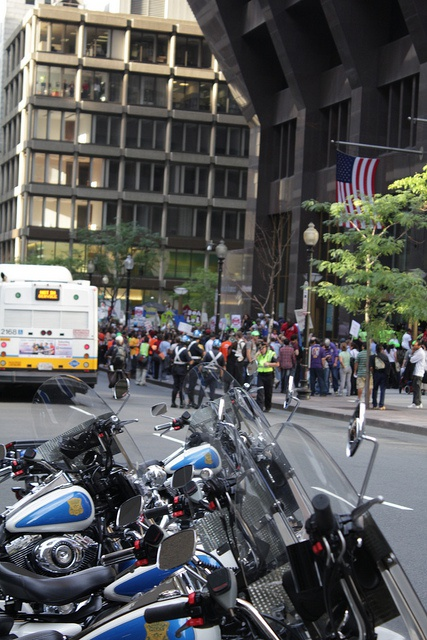Describe the objects in this image and their specific colors. I can see motorcycle in white, gray, darkgray, black, and navy tones, motorcycle in white, black, gray, and darkgray tones, motorcycle in white, black, gray, and lightgray tones, people in white, black, gray, and darkgray tones, and truck in white, lightgray, black, gray, and darkgray tones in this image. 